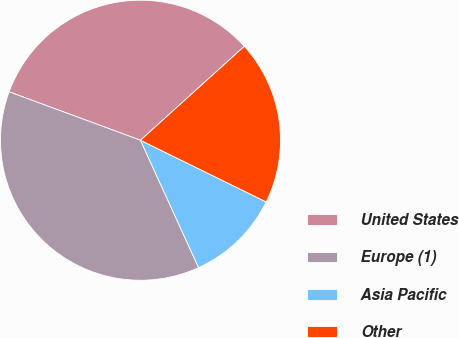Convert chart to OTSL. <chart><loc_0><loc_0><loc_500><loc_500><pie_chart><fcel>United States<fcel>Europe (1)<fcel>Asia Pacific<fcel>Other<nl><fcel>32.68%<fcel>37.43%<fcel>10.93%<fcel>18.96%<nl></chart> 